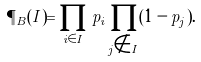<formula> <loc_0><loc_0><loc_500><loc_500>\P _ { B } ( I ) = \prod _ { i \in I } p _ { i } \prod _ { j \notin I } ( 1 - p _ { j } ) .</formula> 